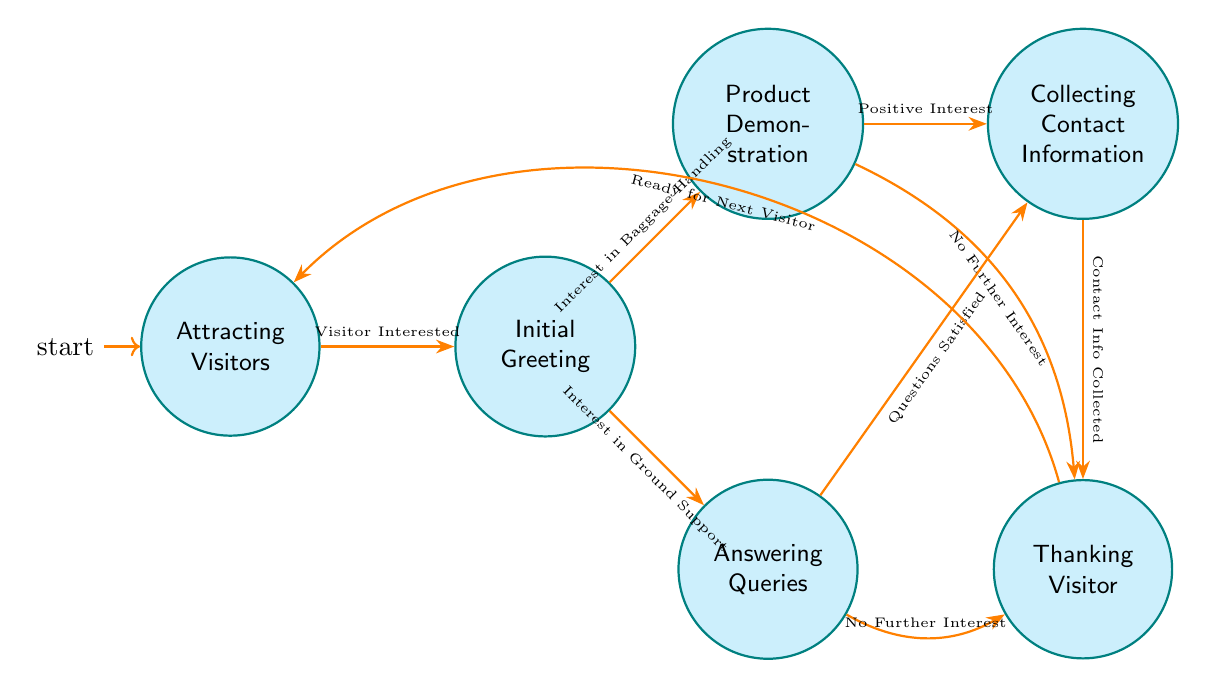What is the first state in the diagram? The first state, indicated by the initial node marker, is "Attracting Visitors".
Answer: Attracting Visitors How many states are represented in the diagram? There are a total of six states displayed in the diagram, which includes all the nodes: Attracting Visitors, Initial Greeting, Product Demonstration, Answering Queries, Collecting Contact Information, and Thanking Visitor.
Answer: 6 What action occurs in the 'Initial Greeting' state? In the 'Initial Greeting' state, three actions occur: "Welcome Visitor", "Brief Introduction of Products", and "Assess Visitor's Interest Area". All these actions focus on engaging the visitor right after their initial approach.
Answer: Welcome Visitor Which state comes after 'Answering Queries' if the visitor has their questions satisfied? If the visitor's questions are satisfied, the next state would be 'Collecting Contact Information', as this transition is indicated by the arrow labeled 'Questions Satisfied'.
Answer: Collecting Contact Information What happens when there is no further interest during a product demonstration? When there is no further interest during a product demonstration, it leads to 'Thanking Visitor', as indicated by the transition labeled 'No Further Interest'.
Answer: Thanking Visitor What condition must be fulfilled for transitioning from 'Collecting Contact Information' to the next state? The condition for transitioning from 'Collecting Contact Information' to the next state, which is 'Thanking Visitor', is that the contact information must be collected, as stated in the transition labeled 'Contact Info Collected'.
Answer: Contact Info Collected Which state has two possible transition outcomes based on the interest type? The state 'Initial Greeting' has two possible transition outcomes: one leading to 'Product Demonstration' if there is interest in baggage handling systems and another leading to 'Answering Queries' if there is interest in ground support equipment.
Answer: Initial Greeting What is the last state before returning to 'Attracting Visitors'? The last state before returning to 'Attracting Visitors' is 'Thanking Visitor', which completes the flow by thanking the visitor and preparing for the next one.
Answer: Thanking Visitor What occurs in the 'Product Demonstration' state? In the 'Product Demonstration' state, three actions take place: "Showcase Baggage Handling System", "Provide Use Cases", and "Highlight Key Features". These actions are intended to inform and engage the visitor about specific products.
Answer: Showcase Baggage Handling System What is the overall flow direction of the diagram? The overall flow direction of the diagram moves generally from left to right, starting from 'Attracting Visitors' and progressing through each state until returning back after 'Thanking Visitor'.
Answer: Left to right 